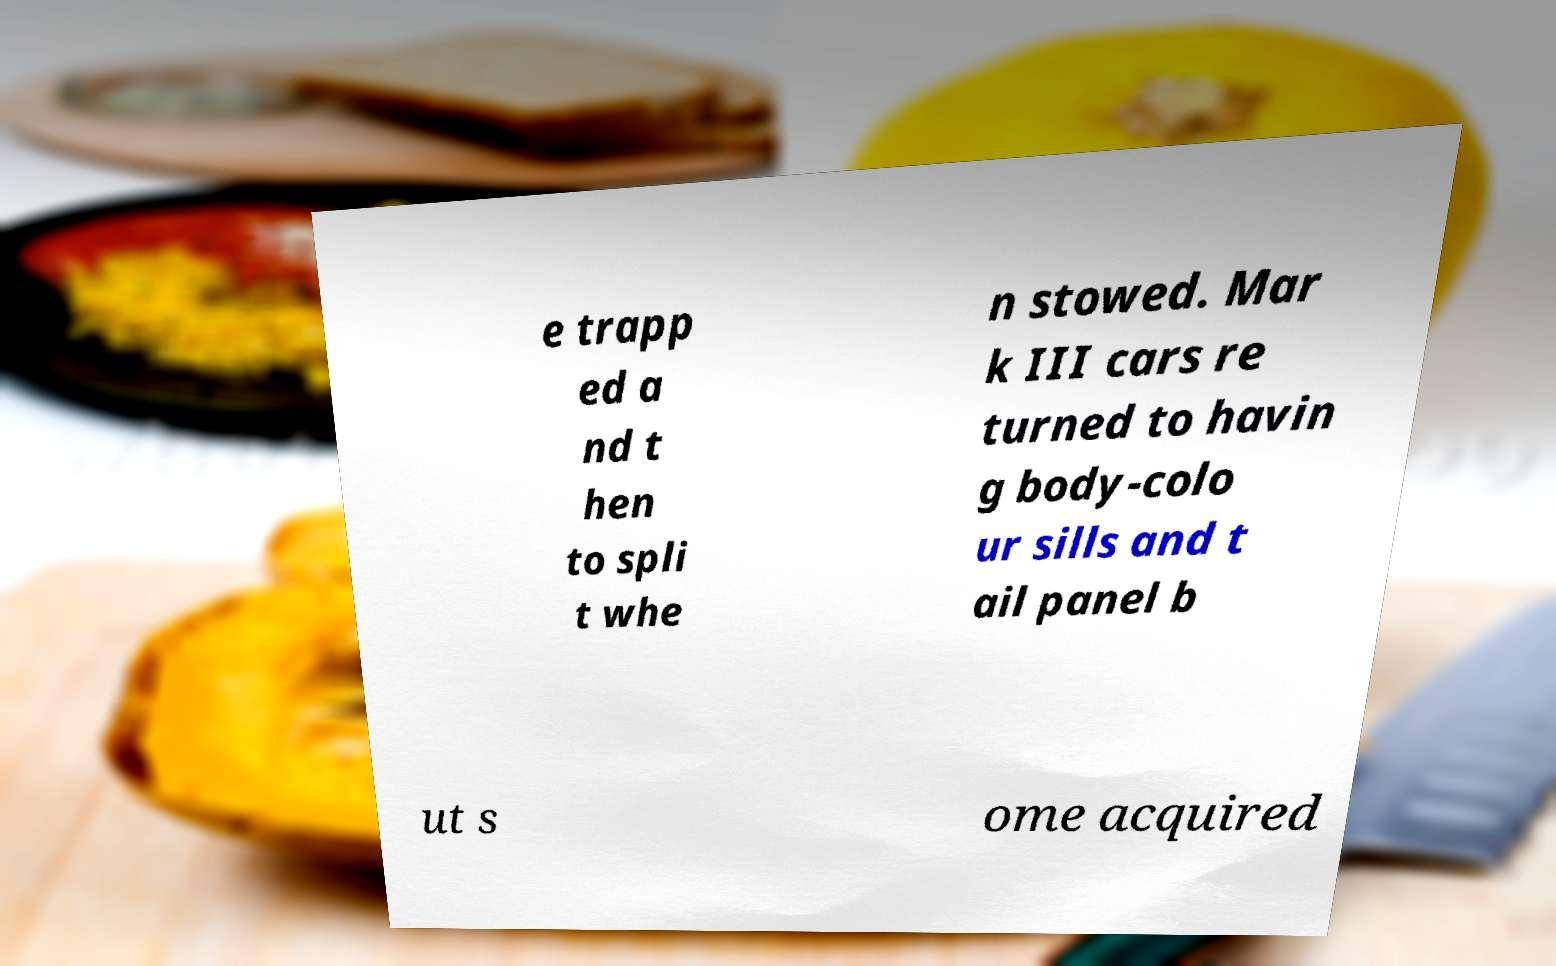What messages or text are displayed in this image? I need them in a readable, typed format. e trapp ed a nd t hen to spli t whe n stowed. Mar k III cars re turned to havin g body-colo ur sills and t ail panel b ut s ome acquired 